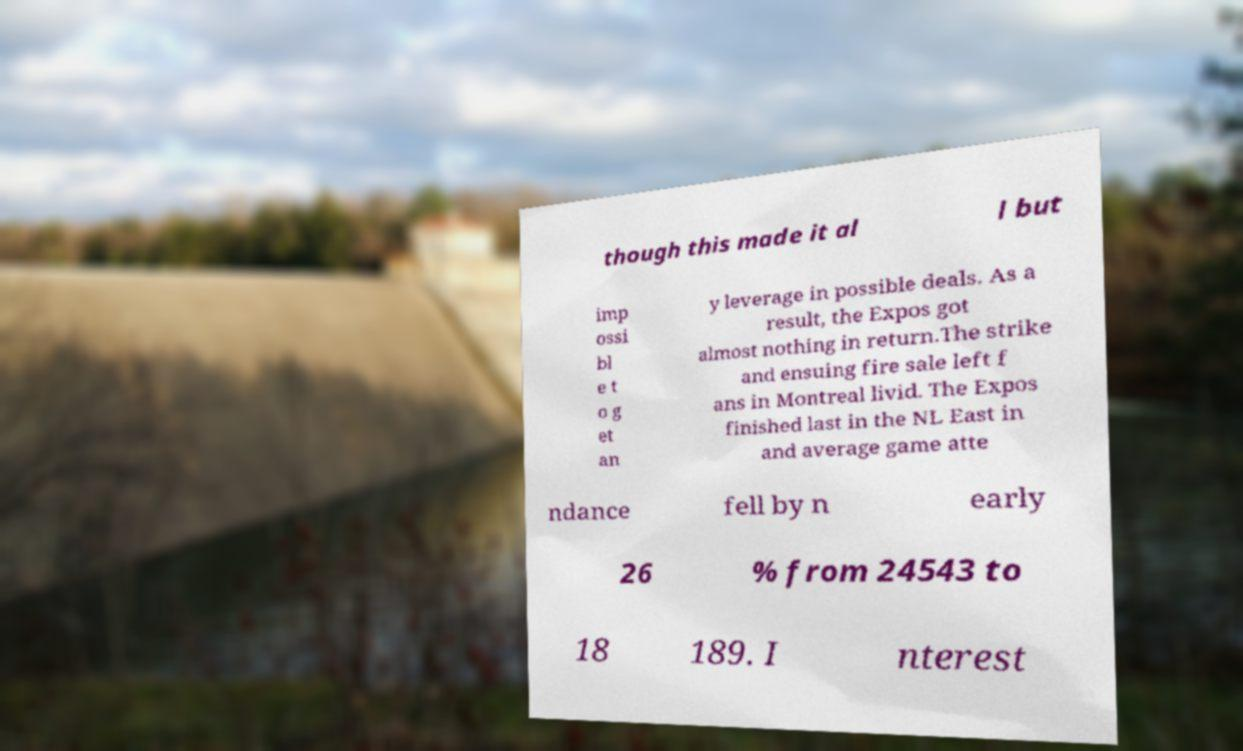Please read and relay the text visible in this image. What does it say? though this made it al l but imp ossi bl e t o g et an y leverage in possible deals. As a result, the Expos got almost nothing in return.The strike and ensuing fire sale left f ans in Montreal livid. The Expos finished last in the NL East in and average game atte ndance fell by n early 26 % from 24543 to 18 189. I nterest 